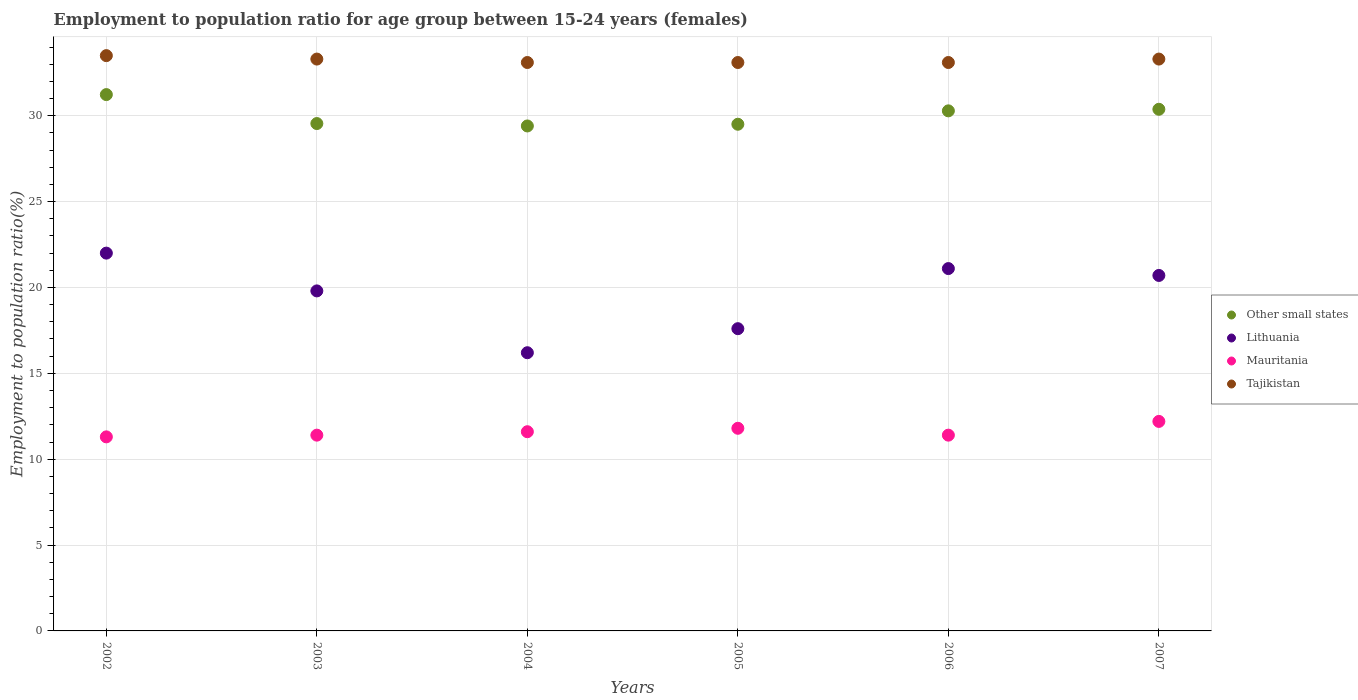What is the employment to population ratio in Mauritania in 2002?
Provide a short and direct response. 11.3. Across all years, what is the minimum employment to population ratio in Other small states?
Ensure brevity in your answer.  29.4. In which year was the employment to population ratio in Tajikistan maximum?
Offer a terse response. 2002. In which year was the employment to population ratio in Other small states minimum?
Make the answer very short. 2004. What is the total employment to population ratio in Other small states in the graph?
Give a very brief answer. 180.35. What is the difference between the employment to population ratio in Tajikistan in 2002 and that in 2003?
Make the answer very short. 0.2. What is the difference between the employment to population ratio in Lithuania in 2002 and the employment to population ratio in Mauritania in 2003?
Give a very brief answer. 10.6. What is the average employment to population ratio in Other small states per year?
Offer a terse response. 30.06. In the year 2003, what is the difference between the employment to population ratio in Tajikistan and employment to population ratio in Mauritania?
Offer a terse response. 21.9. What is the ratio of the employment to population ratio in Mauritania in 2004 to that in 2006?
Your response must be concise. 1.02. Is the employment to population ratio in Tajikistan in 2005 less than that in 2006?
Give a very brief answer. No. What is the difference between the highest and the second highest employment to population ratio in Lithuania?
Give a very brief answer. 0.9. What is the difference between the highest and the lowest employment to population ratio in Tajikistan?
Offer a very short reply. 0.4. Is it the case that in every year, the sum of the employment to population ratio in Tajikistan and employment to population ratio in Other small states  is greater than the sum of employment to population ratio in Mauritania and employment to population ratio in Lithuania?
Your answer should be compact. Yes. How many dotlines are there?
Your response must be concise. 4. How many years are there in the graph?
Keep it short and to the point. 6. Are the values on the major ticks of Y-axis written in scientific E-notation?
Your answer should be very brief. No. Does the graph contain any zero values?
Offer a very short reply. No. How many legend labels are there?
Provide a succinct answer. 4. What is the title of the graph?
Your answer should be very brief. Employment to population ratio for age group between 15-24 years (females). What is the Employment to population ratio(%) in Other small states in 2002?
Ensure brevity in your answer.  31.23. What is the Employment to population ratio(%) in Lithuania in 2002?
Provide a short and direct response. 22. What is the Employment to population ratio(%) in Mauritania in 2002?
Provide a short and direct response. 11.3. What is the Employment to population ratio(%) of Tajikistan in 2002?
Give a very brief answer. 33.5. What is the Employment to population ratio(%) of Other small states in 2003?
Give a very brief answer. 29.55. What is the Employment to population ratio(%) in Lithuania in 2003?
Your answer should be compact. 19.8. What is the Employment to population ratio(%) of Mauritania in 2003?
Offer a terse response. 11.4. What is the Employment to population ratio(%) of Tajikistan in 2003?
Provide a short and direct response. 33.3. What is the Employment to population ratio(%) of Other small states in 2004?
Provide a succinct answer. 29.4. What is the Employment to population ratio(%) in Lithuania in 2004?
Your answer should be compact. 16.2. What is the Employment to population ratio(%) of Mauritania in 2004?
Keep it short and to the point. 11.6. What is the Employment to population ratio(%) in Tajikistan in 2004?
Give a very brief answer. 33.1. What is the Employment to population ratio(%) in Other small states in 2005?
Your response must be concise. 29.5. What is the Employment to population ratio(%) in Lithuania in 2005?
Make the answer very short. 17.6. What is the Employment to population ratio(%) in Mauritania in 2005?
Provide a succinct answer. 11.8. What is the Employment to population ratio(%) of Tajikistan in 2005?
Your response must be concise. 33.1. What is the Employment to population ratio(%) in Other small states in 2006?
Provide a short and direct response. 30.28. What is the Employment to population ratio(%) of Lithuania in 2006?
Make the answer very short. 21.1. What is the Employment to population ratio(%) of Mauritania in 2006?
Make the answer very short. 11.4. What is the Employment to population ratio(%) of Tajikistan in 2006?
Keep it short and to the point. 33.1. What is the Employment to population ratio(%) of Other small states in 2007?
Ensure brevity in your answer.  30.38. What is the Employment to population ratio(%) of Lithuania in 2007?
Make the answer very short. 20.7. What is the Employment to population ratio(%) in Mauritania in 2007?
Keep it short and to the point. 12.2. What is the Employment to population ratio(%) of Tajikistan in 2007?
Provide a short and direct response. 33.3. Across all years, what is the maximum Employment to population ratio(%) of Other small states?
Ensure brevity in your answer.  31.23. Across all years, what is the maximum Employment to population ratio(%) of Lithuania?
Provide a short and direct response. 22. Across all years, what is the maximum Employment to population ratio(%) in Mauritania?
Provide a succinct answer. 12.2. Across all years, what is the maximum Employment to population ratio(%) of Tajikistan?
Provide a succinct answer. 33.5. Across all years, what is the minimum Employment to population ratio(%) of Other small states?
Provide a short and direct response. 29.4. Across all years, what is the minimum Employment to population ratio(%) in Lithuania?
Ensure brevity in your answer.  16.2. Across all years, what is the minimum Employment to population ratio(%) in Mauritania?
Offer a terse response. 11.3. Across all years, what is the minimum Employment to population ratio(%) of Tajikistan?
Give a very brief answer. 33.1. What is the total Employment to population ratio(%) in Other small states in the graph?
Your response must be concise. 180.35. What is the total Employment to population ratio(%) of Lithuania in the graph?
Ensure brevity in your answer.  117.4. What is the total Employment to population ratio(%) of Mauritania in the graph?
Keep it short and to the point. 69.7. What is the total Employment to population ratio(%) of Tajikistan in the graph?
Make the answer very short. 199.4. What is the difference between the Employment to population ratio(%) of Other small states in 2002 and that in 2003?
Provide a succinct answer. 1.69. What is the difference between the Employment to population ratio(%) of Lithuania in 2002 and that in 2003?
Offer a terse response. 2.2. What is the difference between the Employment to population ratio(%) of Mauritania in 2002 and that in 2003?
Your answer should be compact. -0.1. What is the difference between the Employment to population ratio(%) in Other small states in 2002 and that in 2004?
Give a very brief answer. 1.83. What is the difference between the Employment to population ratio(%) in Lithuania in 2002 and that in 2004?
Offer a very short reply. 5.8. What is the difference between the Employment to population ratio(%) in Tajikistan in 2002 and that in 2004?
Provide a succinct answer. 0.4. What is the difference between the Employment to population ratio(%) in Other small states in 2002 and that in 2005?
Give a very brief answer. 1.73. What is the difference between the Employment to population ratio(%) in Other small states in 2002 and that in 2006?
Give a very brief answer. 0.95. What is the difference between the Employment to population ratio(%) in Mauritania in 2002 and that in 2006?
Provide a succinct answer. -0.1. What is the difference between the Employment to population ratio(%) in Other small states in 2002 and that in 2007?
Your answer should be very brief. 0.86. What is the difference between the Employment to population ratio(%) of Lithuania in 2002 and that in 2007?
Ensure brevity in your answer.  1.3. What is the difference between the Employment to population ratio(%) of Other small states in 2003 and that in 2004?
Your answer should be very brief. 0.14. What is the difference between the Employment to population ratio(%) in Lithuania in 2003 and that in 2004?
Offer a very short reply. 3.6. What is the difference between the Employment to population ratio(%) in Mauritania in 2003 and that in 2004?
Give a very brief answer. -0.2. What is the difference between the Employment to population ratio(%) of Other small states in 2003 and that in 2005?
Offer a very short reply. 0.04. What is the difference between the Employment to population ratio(%) of Lithuania in 2003 and that in 2005?
Provide a short and direct response. 2.2. What is the difference between the Employment to population ratio(%) of Mauritania in 2003 and that in 2005?
Make the answer very short. -0.4. What is the difference between the Employment to population ratio(%) of Tajikistan in 2003 and that in 2005?
Make the answer very short. 0.2. What is the difference between the Employment to population ratio(%) in Other small states in 2003 and that in 2006?
Your answer should be very brief. -0.74. What is the difference between the Employment to population ratio(%) of Lithuania in 2003 and that in 2006?
Offer a terse response. -1.3. What is the difference between the Employment to population ratio(%) of Tajikistan in 2003 and that in 2006?
Ensure brevity in your answer.  0.2. What is the difference between the Employment to population ratio(%) of Other small states in 2003 and that in 2007?
Your response must be concise. -0.83. What is the difference between the Employment to population ratio(%) of Mauritania in 2003 and that in 2007?
Offer a terse response. -0.8. What is the difference between the Employment to population ratio(%) of Other small states in 2004 and that in 2005?
Make the answer very short. -0.1. What is the difference between the Employment to population ratio(%) in Mauritania in 2004 and that in 2005?
Provide a short and direct response. -0.2. What is the difference between the Employment to population ratio(%) of Other small states in 2004 and that in 2006?
Provide a short and direct response. -0.88. What is the difference between the Employment to population ratio(%) of Mauritania in 2004 and that in 2006?
Keep it short and to the point. 0.2. What is the difference between the Employment to population ratio(%) of Other small states in 2004 and that in 2007?
Your response must be concise. -0.97. What is the difference between the Employment to population ratio(%) of Lithuania in 2004 and that in 2007?
Make the answer very short. -4.5. What is the difference between the Employment to population ratio(%) of Tajikistan in 2004 and that in 2007?
Offer a very short reply. -0.2. What is the difference between the Employment to population ratio(%) in Other small states in 2005 and that in 2006?
Offer a very short reply. -0.78. What is the difference between the Employment to population ratio(%) in Mauritania in 2005 and that in 2006?
Keep it short and to the point. 0.4. What is the difference between the Employment to population ratio(%) in Other small states in 2005 and that in 2007?
Provide a succinct answer. -0.87. What is the difference between the Employment to population ratio(%) in Lithuania in 2005 and that in 2007?
Give a very brief answer. -3.1. What is the difference between the Employment to population ratio(%) in Mauritania in 2005 and that in 2007?
Your answer should be very brief. -0.4. What is the difference between the Employment to population ratio(%) in Other small states in 2006 and that in 2007?
Ensure brevity in your answer.  -0.09. What is the difference between the Employment to population ratio(%) in Other small states in 2002 and the Employment to population ratio(%) in Lithuania in 2003?
Give a very brief answer. 11.43. What is the difference between the Employment to population ratio(%) of Other small states in 2002 and the Employment to population ratio(%) of Mauritania in 2003?
Provide a succinct answer. 19.83. What is the difference between the Employment to population ratio(%) in Other small states in 2002 and the Employment to population ratio(%) in Tajikistan in 2003?
Your answer should be compact. -2.07. What is the difference between the Employment to population ratio(%) in Mauritania in 2002 and the Employment to population ratio(%) in Tajikistan in 2003?
Make the answer very short. -22. What is the difference between the Employment to population ratio(%) in Other small states in 2002 and the Employment to population ratio(%) in Lithuania in 2004?
Offer a very short reply. 15.03. What is the difference between the Employment to population ratio(%) in Other small states in 2002 and the Employment to population ratio(%) in Mauritania in 2004?
Provide a succinct answer. 19.63. What is the difference between the Employment to population ratio(%) in Other small states in 2002 and the Employment to population ratio(%) in Tajikistan in 2004?
Make the answer very short. -1.87. What is the difference between the Employment to population ratio(%) of Lithuania in 2002 and the Employment to population ratio(%) of Mauritania in 2004?
Provide a succinct answer. 10.4. What is the difference between the Employment to population ratio(%) in Mauritania in 2002 and the Employment to population ratio(%) in Tajikistan in 2004?
Your answer should be very brief. -21.8. What is the difference between the Employment to population ratio(%) of Other small states in 2002 and the Employment to population ratio(%) of Lithuania in 2005?
Offer a terse response. 13.63. What is the difference between the Employment to population ratio(%) in Other small states in 2002 and the Employment to population ratio(%) in Mauritania in 2005?
Your response must be concise. 19.43. What is the difference between the Employment to population ratio(%) in Other small states in 2002 and the Employment to population ratio(%) in Tajikistan in 2005?
Keep it short and to the point. -1.87. What is the difference between the Employment to population ratio(%) of Lithuania in 2002 and the Employment to population ratio(%) of Mauritania in 2005?
Keep it short and to the point. 10.2. What is the difference between the Employment to population ratio(%) of Lithuania in 2002 and the Employment to population ratio(%) of Tajikistan in 2005?
Provide a short and direct response. -11.1. What is the difference between the Employment to population ratio(%) in Mauritania in 2002 and the Employment to population ratio(%) in Tajikistan in 2005?
Your answer should be compact. -21.8. What is the difference between the Employment to population ratio(%) of Other small states in 2002 and the Employment to population ratio(%) of Lithuania in 2006?
Provide a succinct answer. 10.13. What is the difference between the Employment to population ratio(%) in Other small states in 2002 and the Employment to population ratio(%) in Mauritania in 2006?
Your answer should be compact. 19.83. What is the difference between the Employment to population ratio(%) of Other small states in 2002 and the Employment to population ratio(%) of Tajikistan in 2006?
Make the answer very short. -1.87. What is the difference between the Employment to population ratio(%) of Lithuania in 2002 and the Employment to population ratio(%) of Tajikistan in 2006?
Provide a short and direct response. -11.1. What is the difference between the Employment to population ratio(%) in Mauritania in 2002 and the Employment to population ratio(%) in Tajikistan in 2006?
Your answer should be very brief. -21.8. What is the difference between the Employment to population ratio(%) of Other small states in 2002 and the Employment to population ratio(%) of Lithuania in 2007?
Provide a succinct answer. 10.53. What is the difference between the Employment to population ratio(%) of Other small states in 2002 and the Employment to population ratio(%) of Mauritania in 2007?
Offer a terse response. 19.03. What is the difference between the Employment to population ratio(%) in Other small states in 2002 and the Employment to population ratio(%) in Tajikistan in 2007?
Your answer should be very brief. -2.07. What is the difference between the Employment to population ratio(%) of Other small states in 2003 and the Employment to population ratio(%) of Lithuania in 2004?
Provide a succinct answer. 13.35. What is the difference between the Employment to population ratio(%) of Other small states in 2003 and the Employment to population ratio(%) of Mauritania in 2004?
Ensure brevity in your answer.  17.95. What is the difference between the Employment to population ratio(%) in Other small states in 2003 and the Employment to population ratio(%) in Tajikistan in 2004?
Offer a very short reply. -3.55. What is the difference between the Employment to population ratio(%) of Lithuania in 2003 and the Employment to population ratio(%) of Mauritania in 2004?
Provide a short and direct response. 8.2. What is the difference between the Employment to population ratio(%) in Lithuania in 2003 and the Employment to population ratio(%) in Tajikistan in 2004?
Offer a terse response. -13.3. What is the difference between the Employment to population ratio(%) in Mauritania in 2003 and the Employment to population ratio(%) in Tajikistan in 2004?
Ensure brevity in your answer.  -21.7. What is the difference between the Employment to population ratio(%) in Other small states in 2003 and the Employment to population ratio(%) in Lithuania in 2005?
Offer a very short reply. 11.95. What is the difference between the Employment to population ratio(%) of Other small states in 2003 and the Employment to population ratio(%) of Mauritania in 2005?
Make the answer very short. 17.75. What is the difference between the Employment to population ratio(%) of Other small states in 2003 and the Employment to population ratio(%) of Tajikistan in 2005?
Offer a terse response. -3.55. What is the difference between the Employment to population ratio(%) in Mauritania in 2003 and the Employment to population ratio(%) in Tajikistan in 2005?
Your response must be concise. -21.7. What is the difference between the Employment to population ratio(%) in Other small states in 2003 and the Employment to population ratio(%) in Lithuania in 2006?
Ensure brevity in your answer.  8.45. What is the difference between the Employment to population ratio(%) in Other small states in 2003 and the Employment to population ratio(%) in Mauritania in 2006?
Your answer should be compact. 18.15. What is the difference between the Employment to population ratio(%) of Other small states in 2003 and the Employment to population ratio(%) of Tajikistan in 2006?
Make the answer very short. -3.55. What is the difference between the Employment to population ratio(%) of Lithuania in 2003 and the Employment to population ratio(%) of Tajikistan in 2006?
Ensure brevity in your answer.  -13.3. What is the difference between the Employment to population ratio(%) in Mauritania in 2003 and the Employment to population ratio(%) in Tajikistan in 2006?
Offer a terse response. -21.7. What is the difference between the Employment to population ratio(%) in Other small states in 2003 and the Employment to population ratio(%) in Lithuania in 2007?
Your answer should be compact. 8.85. What is the difference between the Employment to population ratio(%) of Other small states in 2003 and the Employment to population ratio(%) of Mauritania in 2007?
Ensure brevity in your answer.  17.35. What is the difference between the Employment to population ratio(%) in Other small states in 2003 and the Employment to population ratio(%) in Tajikistan in 2007?
Offer a very short reply. -3.75. What is the difference between the Employment to population ratio(%) of Mauritania in 2003 and the Employment to population ratio(%) of Tajikistan in 2007?
Give a very brief answer. -21.9. What is the difference between the Employment to population ratio(%) in Other small states in 2004 and the Employment to population ratio(%) in Lithuania in 2005?
Your answer should be very brief. 11.8. What is the difference between the Employment to population ratio(%) of Other small states in 2004 and the Employment to population ratio(%) of Mauritania in 2005?
Your answer should be compact. 17.6. What is the difference between the Employment to population ratio(%) in Other small states in 2004 and the Employment to population ratio(%) in Tajikistan in 2005?
Offer a very short reply. -3.7. What is the difference between the Employment to population ratio(%) of Lithuania in 2004 and the Employment to population ratio(%) of Tajikistan in 2005?
Offer a terse response. -16.9. What is the difference between the Employment to population ratio(%) of Mauritania in 2004 and the Employment to population ratio(%) of Tajikistan in 2005?
Your response must be concise. -21.5. What is the difference between the Employment to population ratio(%) of Other small states in 2004 and the Employment to population ratio(%) of Lithuania in 2006?
Your answer should be compact. 8.3. What is the difference between the Employment to population ratio(%) of Other small states in 2004 and the Employment to population ratio(%) of Mauritania in 2006?
Provide a short and direct response. 18. What is the difference between the Employment to population ratio(%) of Other small states in 2004 and the Employment to population ratio(%) of Tajikistan in 2006?
Offer a terse response. -3.7. What is the difference between the Employment to population ratio(%) of Lithuania in 2004 and the Employment to population ratio(%) of Tajikistan in 2006?
Give a very brief answer. -16.9. What is the difference between the Employment to population ratio(%) of Mauritania in 2004 and the Employment to population ratio(%) of Tajikistan in 2006?
Provide a short and direct response. -21.5. What is the difference between the Employment to population ratio(%) of Other small states in 2004 and the Employment to population ratio(%) of Lithuania in 2007?
Your answer should be compact. 8.7. What is the difference between the Employment to population ratio(%) in Other small states in 2004 and the Employment to population ratio(%) in Mauritania in 2007?
Make the answer very short. 17.2. What is the difference between the Employment to population ratio(%) of Other small states in 2004 and the Employment to population ratio(%) of Tajikistan in 2007?
Offer a very short reply. -3.9. What is the difference between the Employment to population ratio(%) in Lithuania in 2004 and the Employment to population ratio(%) in Mauritania in 2007?
Provide a short and direct response. 4. What is the difference between the Employment to population ratio(%) of Lithuania in 2004 and the Employment to population ratio(%) of Tajikistan in 2007?
Offer a very short reply. -17.1. What is the difference between the Employment to population ratio(%) of Mauritania in 2004 and the Employment to population ratio(%) of Tajikistan in 2007?
Keep it short and to the point. -21.7. What is the difference between the Employment to population ratio(%) of Other small states in 2005 and the Employment to population ratio(%) of Lithuania in 2006?
Give a very brief answer. 8.4. What is the difference between the Employment to population ratio(%) of Other small states in 2005 and the Employment to population ratio(%) of Mauritania in 2006?
Ensure brevity in your answer.  18.1. What is the difference between the Employment to population ratio(%) of Other small states in 2005 and the Employment to population ratio(%) of Tajikistan in 2006?
Make the answer very short. -3.6. What is the difference between the Employment to population ratio(%) in Lithuania in 2005 and the Employment to population ratio(%) in Tajikistan in 2006?
Provide a short and direct response. -15.5. What is the difference between the Employment to population ratio(%) of Mauritania in 2005 and the Employment to population ratio(%) of Tajikistan in 2006?
Give a very brief answer. -21.3. What is the difference between the Employment to population ratio(%) of Other small states in 2005 and the Employment to population ratio(%) of Lithuania in 2007?
Offer a very short reply. 8.8. What is the difference between the Employment to population ratio(%) of Other small states in 2005 and the Employment to population ratio(%) of Mauritania in 2007?
Keep it short and to the point. 17.3. What is the difference between the Employment to population ratio(%) in Other small states in 2005 and the Employment to population ratio(%) in Tajikistan in 2007?
Offer a very short reply. -3.8. What is the difference between the Employment to population ratio(%) of Lithuania in 2005 and the Employment to population ratio(%) of Tajikistan in 2007?
Keep it short and to the point. -15.7. What is the difference between the Employment to population ratio(%) in Mauritania in 2005 and the Employment to population ratio(%) in Tajikistan in 2007?
Your response must be concise. -21.5. What is the difference between the Employment to population ratio(%) of Other small states in 2006 and the Employment to population ratio(%) of Lithuania in 2007?
Offer a very short reply. 9.58. What is the difference between the Employment to population ratio(%) of Other small states in 2006 and the Employment to population ratio(%) of Mauritania in 2007?
Your response must be concise. 18.08. What is the difference between the Employment to population ratio(%) in Other small states in 2006 and the Employment to population ratio(%) in Tajikistan in 2007?
Your response must be concise. -3.02. What is the difference between the Employment to population ratio(%) of Lithuania in 2006 and the Employment to population ratio(%) of Mauritania in 2007?
Provide a short and direct response. 8.9. What is the difference between the Employment to population ratio(%) in Lithuania in 2006 and the Employment to population ratio(%) in Tajikistan in 2007?
Keep it short and to the point. -12.2. What is the difference between the Employment to population ratio(%) of Mauritania in 2006 and the Employment to population ratio(%) of Tajikistan in 2007?
Keep it short and to the point. -21.9. What is the average Employment to population ratio(%) in Other small states per year?
Your answer should be very brief. 30.06. What is the average Employment to population ratio(%) of Lithuania per year?
Your answer should be very brief. 19.57. What is the average Employment to population ratio(%) of Mauritania per year?
Your answer should be compact. 11.62. What is the average Employment to population ratio(%) in Tajikistan per year?
Ensure brevity in your answer.  33.23. In the year 2002, what is the difference between the Employment to population ratio(%) of Other small states and Employment to population ratio(%) of Lithuania?
Offer a very short reply. 9.23. In the year 2002, what is the difference between the Employment to population ratio(%) of Other small states and Employment to population ratio(%) of Mauritania?
Your answer should be very brief. 19.93. In the year 2002, what is the difference between the Employment to population ratio(%) in Other small states and Employment to population ratio(%) in Tajikistan?
Your answer should be very brief. -2.27. In the year 2002, what is the difference between the Employment to population ratio(%) in Lithuania and Employment to population ratio(%) in Tajikistan?
Ensure brevity in your answer.  -11.5. In the year 2002, what is the difference between the Employment to population ratio(%) of Mauritania and Employment to population ratio(%) of Tajikistan?
Provide a succinct answer. -22.2. In the year 2003, what is the difference between the Employment to population ratio(%) of Other small states and Employment to population ratio(%) of Lithuania?
Make the answer very short. 9.75. In the year 2003, what is the difference between the Employment to population ratio(%) of Other small states and Employment to population ratio(%) of Mauritania?
Offer a very short reply. 18.15. In the year 2003, what is the difference between the Employment to population ratio(%) of Other small states and Employment to population ratio(%) of Tajikistan?
Ensure brevity in your answer.  -3.75. In the year 2003, what is the difference between the Employment to population ratio(%) in Lithuania and Employment to population ratio(%) in Mauritania?
Your answer should be compact. 8.4. In the year 2003, what is the difference between the Employment to population ratio(%) of Mauritania and Employment to population ratio(%) of Tajikistan?
Ensure brevity in your answer.  -21.9. In the year 2004, what is the difference between the Employment to population ratio(%) of Other small states and Employment to population ratio(%) of Lithuania?
Ensure brevity in your answer.  13.2. In the year 2004, what is the difference between the Employment to population ratio(%) of Other small states and Employment to population ratio(%) of Mauritania?
Your response must be concise. 17.8. In the year 2004, what is the difference between the Employment to population ratio(%) of Other small states and Employment to population ratio(%) of Tajikistan?
Offer a terse response. -3.7. In the year 2004, what is the difference between the Employment to population ratio(%) of Lithuania and Employment to population ratio(%) of Mauritania?
Your response must be concise. 4.6. In the year 2004, what is the difference between the Employment to population ratio(%) in Lithuania and Employment to population ratio(%) in Tajikistan?
Your answer should be compact. -16.9. In the year 2004, what is the difference between the Employment to population ratio(%) of Mauritania and Employment to population ratio(%) of Tajikistan?
Your answer should be compact. -21.5. In the year 2005, what is the difference between the Employment to population ratio(%) of Other small states and Employment to population ratio(%) of Lithuania?
Keep it short and to the point. 11.9. In the year 2005, what is the difference between the Employment to population ratio(%) of Other small states and Employment to population ratio(%) of Mauritania?
Offer a terse response. 17.7. In the year 2005, what is the difference between the Employment to population ratio(%) of Other small states and Employment to population ratio(%) of Tajikistan?
Your answer should be very brief. -3.6. In the year 2005, what is the difference between the Employment to population ratio(%) of Lithuania and Employment to population ratio(%) of Tajikistan?
Give a very brief answer. -15.5. In the year 2005, what is the difference between the Employment to population ratio(%) of Mauritania and Employment to population ratio(%) of Tajikistan?
Your response must be concise. -21.3. In the year 2006, what is the difference between the Employment to population ratio(%) in Other small states and Employment to population ratio(%) in Lithuania?
Provide a succinct answer. 9.18. In the year 2006, what is the difference between the Employment to population ratio(%) in Other small states and Employment to population ratio(%) in Mauritania?
Give a very brief answer. 18.88. In the year 2006, what is the difference between the Employment to population ratio(%) in Other small states and Employment to population ratio(%) in Tajikistan?
Make the answer very short. -2.82. In the year 2006, what is the difference between the Employment to population ratio(%) in Lithuania and Employment to population ratio(%) in Tajikistan?
Your answer should be very brief. -12. In the year 2006, what is the difference between the Employment to population ratio(%) in Mauritania and Employment to population ratio(%) in Tajikistan?
Your response must be concise. -21.7. In the year 2007, what is the difference between the Employment to population ratio(%) in Other small states and Employment to population ratio(%) in Lithuania?
Make the answer very short. 9.68. In the year 2007, what is the difference between the Employment to population ratio(%) in Other small states and Employment to population ratio(%) in Mauritania?
Offer a terse response. 18.18. In the year 2007, what is the difference between the Employment to population ratio(%) in Other small states and Employment to population ratio(%) in Tajikistan?
Provide a succinct answer. -2.92. In the year 2007, what is the difference between the Employment to population ratio(%) of Mauritania and Employment to population ratio(%) of Tajikistan?
Make the answer very short. -21.1. What is the ratio of the Employment to population ratio(%) in Other small states in 2002 to that in 2003?
Ensure brevity in your answer.  1.06. What is the ratio of the Employment to population ratio(%) of Lithuania in 2002 to that in 2003?
Give a very brief answer. 1.11. What is the ratio of the Employment to population ratio(%) of Mauritania in 2002 to that in 2003?
Make the answer very short. 0.99. What is the ratio of the Employment to population ratio(%) of Tajikistan in 2002 to that in 2003?
Provide a short and direct response. 1.01. What is the ratio of the Employment to population ratio(%) of Other small states in 2002 to that in 2004?
Provide a short and direct response. 1.06. What is the ratio of the Employment to population ratio(%) of Lithuania in 2002 to that in 2004?
Your answer should be compact. 1.36. What is the ratio of the Employment to population ratio(%) of Mauritania in 2002 to that in 2004?
Your response must be concise. 0.97. What is the ratio of the Employment to population ratio(%) in Tajikistan in 2002 to that in 2004?
Provide a succinct answer. 1.01. What is the ratio of the Employment to population ratio(%) of Other small states in 2002 to that in 2005?
Offer a very short reply. 1.06. What is the ratio of the Employment to population ratio(%) of Lithuania in 2002 to that in 2005?
Your answer should be very brief. 1.25. What is the ratio of the Employment to population ratio(%) of Mauritania in 2002 to that in 2005?
Make the answer very short. 0.96. What is the ratio of the Employment to population ratio(%) in Tajikistan in 2002 to that in 2005?
Offer a terse response. 1.01. What is the ratio of the Employment to population ratio(%) of Other small states in 2002 to that in 2006?
Your response must be concise. 1.03. What is the ratio of the Employment to population ratio(%) in Lithuania in 2002 to that in 2006?
Make the answer very short. 1.04. What is the ratio of the Employment to population ratio(%) of Mauritania in 2002 to that in 2006?
Make the answer very short. 0.99. What is the ratio of the Employment to population ratio(%) of Tajikistan in 2002 to that in 2006?
Give a very brief answer. 1.01. What is the ratio of the Employment to population ratio(%) in Other small states in 2002 to that in 2007?
Provide a succinct answer. 1.03. What is the ratio of the Employment to population ratio(%) of Lithuania in 2002 to that in 2007?
Keep it short and to the point. 1.06. What is the ratio of the Employment to population ratio(%) of Mauritania in 2002 to that in 2007?
Ensure brevity in your answer.  0.93. What is the ratio of the Employment to population ratio(%) of Other small states in 2003 to that in 2004?
Provide a short and direct response. 1. What is the ratio of the Employment to population ratio(%) in Lithuania in 2003 to that in 2004?
Your response must be concise. 1.22. What is the ratio of the Employment to population ratio(%) in Mauritania in 2003 to that in 2004?
Ensure brevity in your answer.  0.98. What is the ratio of the Employment to population ratio(%) in Tajikistan in 2003 to that in 2004?
Keep it short and to the point. 1.01. What is the ratio of the Employment to population ratio(%) of Other small states in 2003 to that in 2005?
Your response must be concise. 1. What is the ratio of the Employment to population ratio(%) of Lithuania in 2003 to that in 2005?
Your answer should be very brief. 1.12. What is the ratio of the Employment to population ratio(%) in Mauritania in 2003 to that in 2005?
Offer a terse response. 0.97. What is the ratio of the Employment to population ratio(%) in Other small states in 2003 to that in 2006?
Provide a succinct answer. 0.98. What is the ratio of the Employment to population ratio(%) of Lithuania in 2003 to that in 2006?
Ensure brevity in your answer.  0.94. What is the ratio of the Employment to population ratio(%) in Mauritania in 2003 to that in 2006?
Your answer should be compact. 1. What is the ratio of the Employment to population ratio(%) of Other small states in 2003 to that in 2007?
Offer a terse response. 0.97. What is the ratio of the Employment to population ratio(%) in Lithuania in 2003 to that in 2007?
Offer a terse response. 0.96. What is the ratio of the Employment to population ratio(%) in Mauritania in 2003 to that in 2007?
Your answer should be compact. 0.93. What is the ratio of the Employment to population ratio(%) of Tajikistan in 2003 to that in 2007?
Keep it short and to the point. 1. What is the ratio of the Employment to population ratio(%) of Other small states in 2004 to that in 2005?
Offer a very short reply. 1. What is the ratio of the Employment to population ratio(%) of Lithuania in 2004 to that in 2005?
Give a very brief answer. 0.92. What is the ratio of the Employment to population ratio(%) of Mauritania in 2004 to that in 2005?
Provide a short and direct response. 0.98. What is the ratio of the Employment to population ratio(%) of Tajikistan in 2004 to that in 2005?
Provide a succinct answer. 1. What is the ratio of the Employment to population ratio(%) of Other small states in 2004 to that in 2006?
Offer a very short reply. 0.97. What is the ratio of the Employment to population ratio(%) of Lithuania in 2004 to that in 2006?
Provide a succinct answer. 0.77. What is the ratio of the Employment to population ratio(%) in Mauritania in 2004 to that in 2006?
Offer a terse response. 1.02. What is the ratio of the Employment to population ratio(%) of Lithuania in 2004 to that in 2007?
Provide a succinct answer. 0.78. What is the ratio of the Employment to population ratio(%) in Mauritania in 2004 to that in 2007?
Your answer should be compact. 0.95. What is the ratio of the Employment to population ratio(%) in Tajikistan in 2004 to that in 2007?
Your answer should be compact. 0.99. What is the ratio of the Employment to population ratio(%) in Other small states in 2005 to that in 2006?
Keep it short and to the point. 0.97. What is the ratio of the Employment to population ratio(%) in Lithuania in 2005 to that in 2006?
Make the answer very short. 0.83. What is the ratio of the Employment to population ratio(%) of Mauritania in 2005 to that in 2006?
Your answer should be very brief. 1.04. What is the ratio of the Employment to population ratio(%) of Tajikistan in 2005 to that in 2006?
Provide a short and direct response. 1. What is the ratio of the Employment to population ratio(%) in Other small states in 2005 to that in 2007?
Keep it short and to the point. 0.97. What is the ratio of the Employment to population ratio(%) of Lithuania in 2005 to that in 2007?
Ensure brevity in your answer.  0.85. What is the ratio of the Employment to population ratio(%) of Mauritania in 2005 to that in 2007?
Provide a succinct answer. 0.97. What is the ratio of the Employment to population ratio(%) in Other small states in 2006 to that in 2007?
Give a very brief answer. 1. What is the ratio of the Employment to population ratio(%) of Lithuania in 2006 to that in 2007?
Provide a short and direct response. 1.02. What is the ratio of the Employment to population ratio(%) in Mauritania in 2006 to that in 2007?
Your answer should be very brief. 0.93. What is the ratio of the Employment to population ratio(%) of Tajikistan in 2006 to that in 2007?
Provide a short and direct response. 0.99. What is the difference between the highest and the second highest Employment to population ratio(%) in Other small states?
Keep it short and to the point. 0.86. What is the difference between the highest and the second highest Employment to population ratio(%) of Lithuania?
Give a very brief answer. 0.9. What is the difference between the highest and the second highest Employment to population ratio(%) of Mauritania?
Provide a short and direct response. 0.4. What is the difference between the highest and the lowest Employment to population ratio(%) in Other small states?
Provide a short and direct response. 1.83. What is the difference between the highest and the lowest Employment to population ratio(%) in Mauritania?
Give a very brief answer. 0.9. 